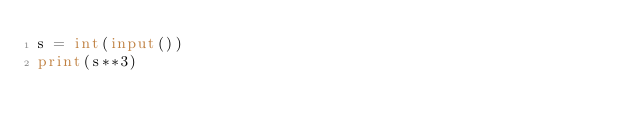Convert code to text. <code><loc_0><loc_0><loc_500><loc_500><_Python_>s = int(input())
print(s**3)
</code> 